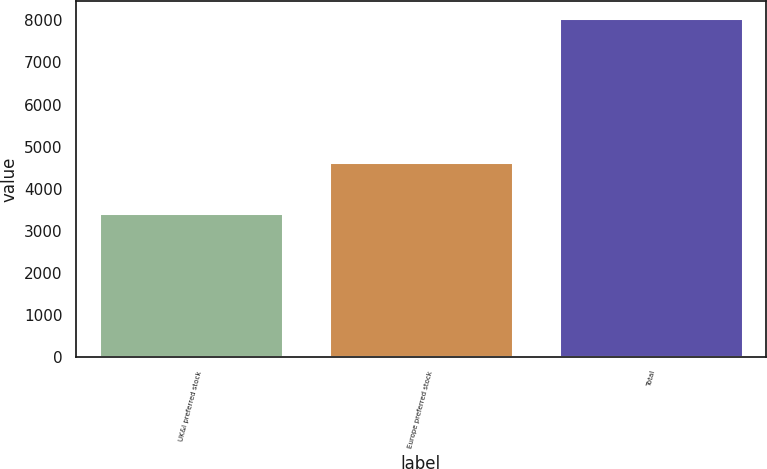<chart> <loc_0><loc_0><loc_500><loc_500><bar_chart><fcel>UK&I preferred stock<fcel>Europe preferred stock<fcel>Total<nl><fcel>3414<fcel>4634<fcel>8048<nl></chart> 